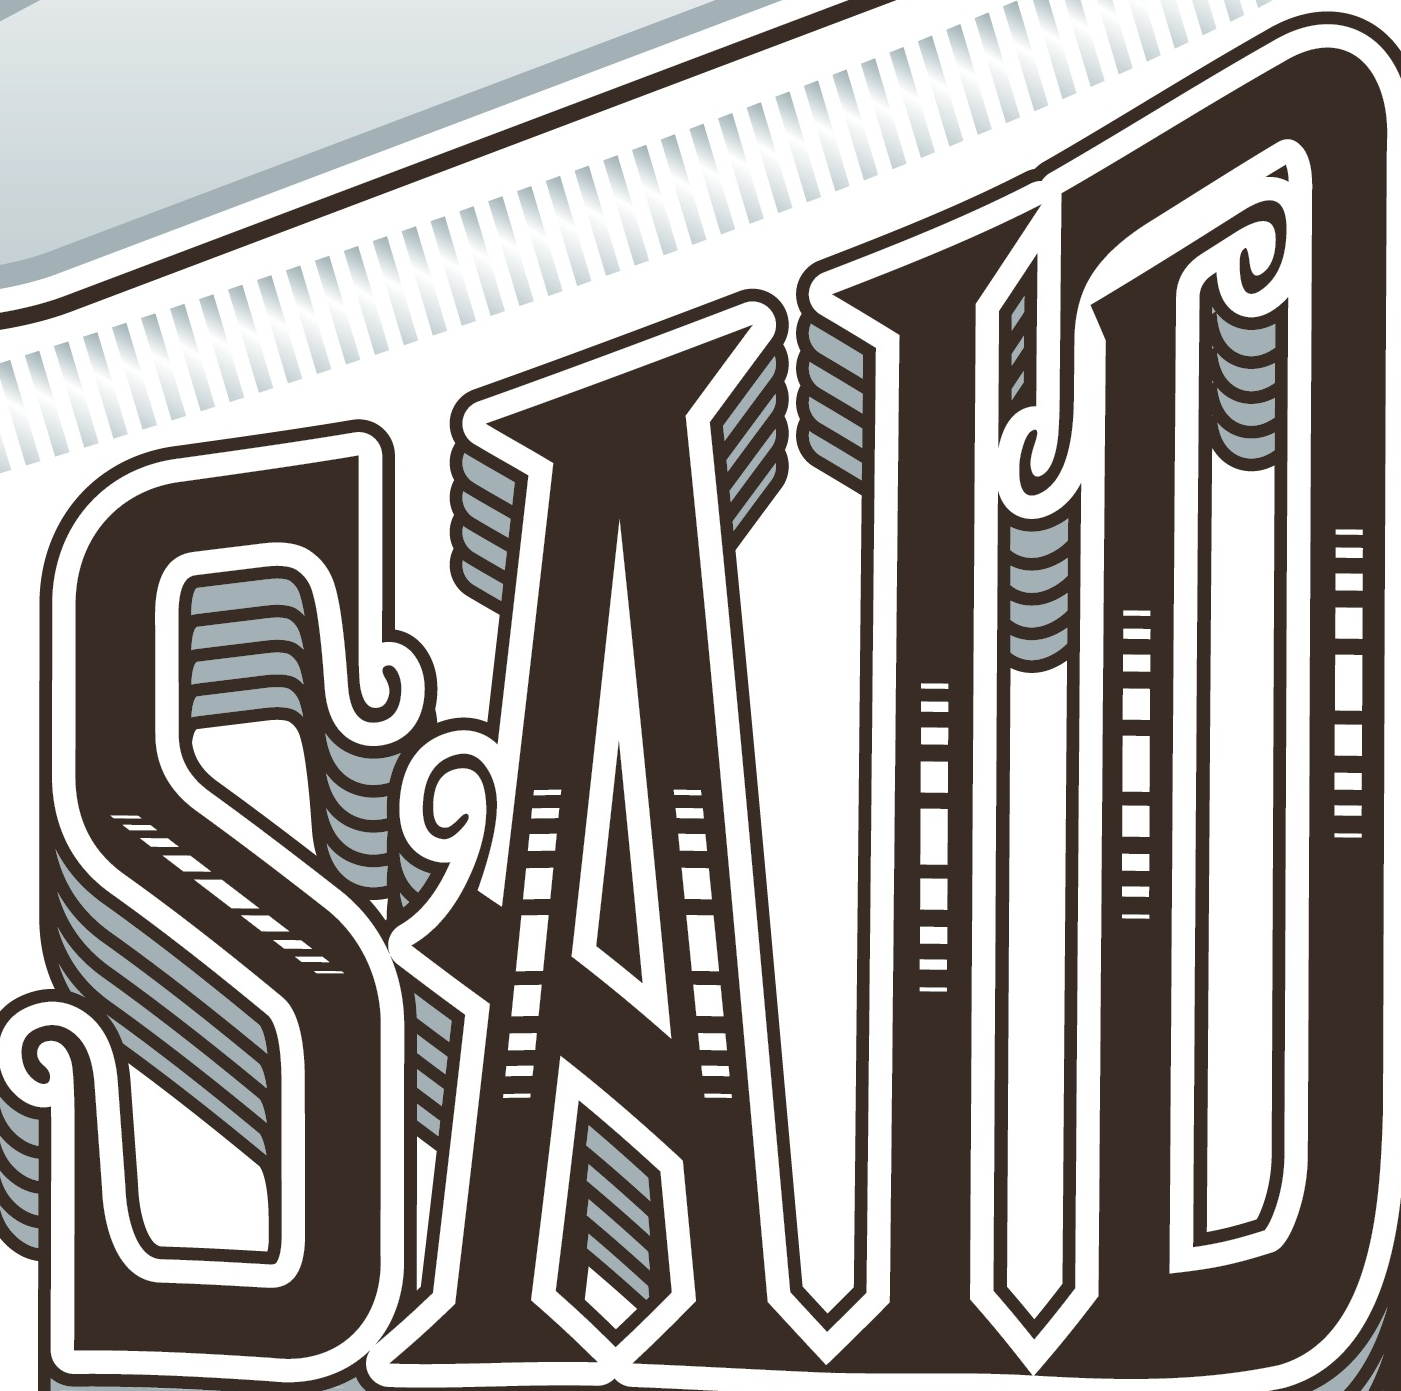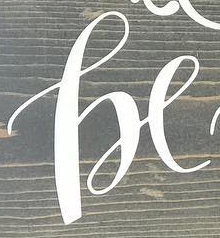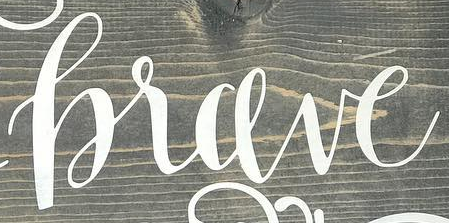Read the text from these images in sequence, separated by a semicolon. SAID; he; hrave 